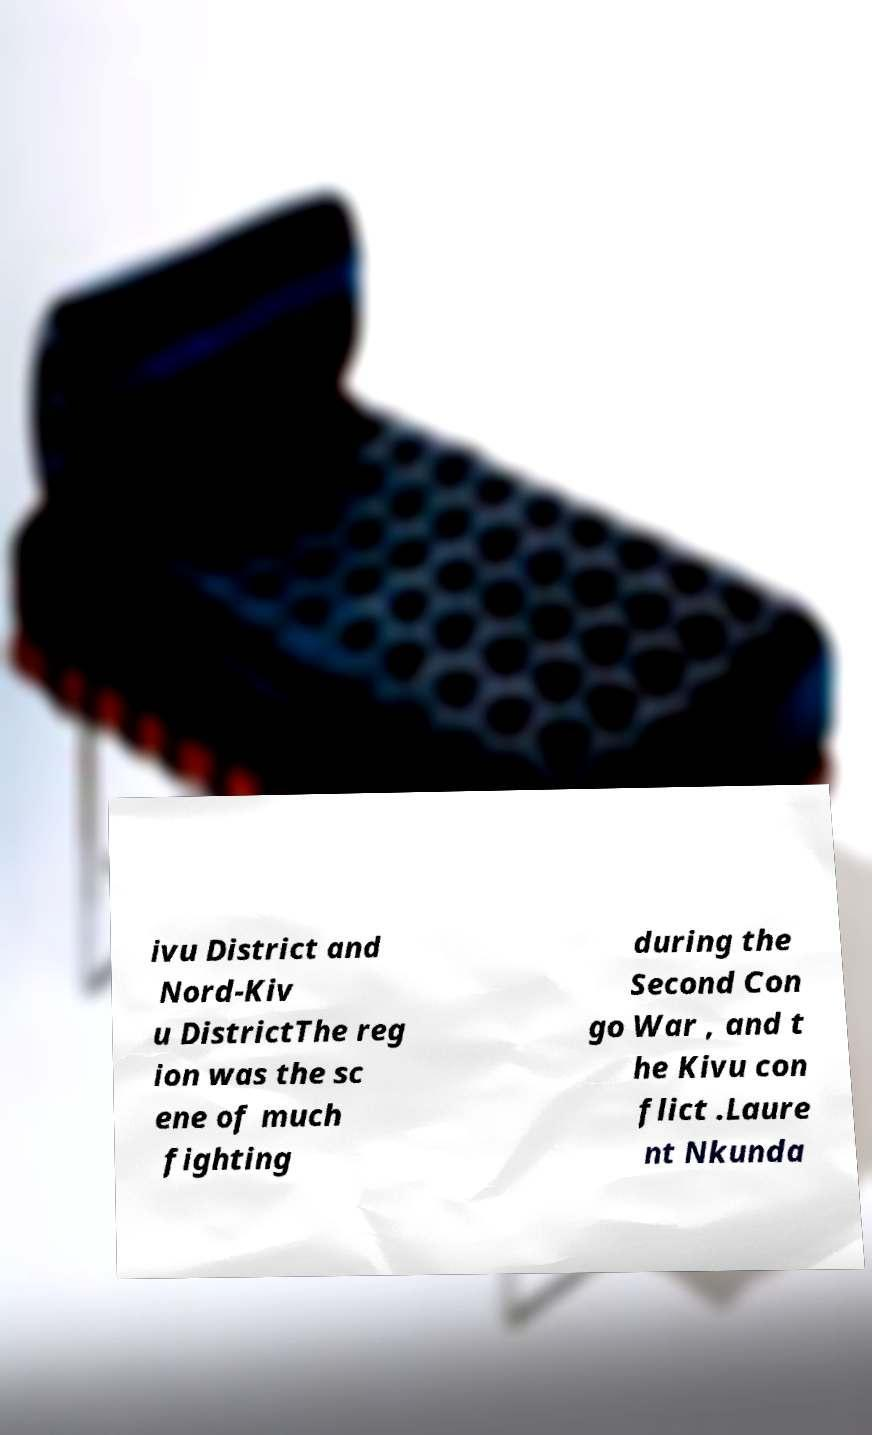What messages or text are displayed in this image? I need them in a readable, typed format. ivu District and Nord-Kiv u DistrictThe reg ion was the sc ene of much fighting during the Second Con go War , and t he Kivu con flict .Laure nt Nkunda 